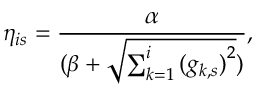<formula> <loc_0><loc_0><loc_500><loc_500>\eta _ { i s } = \frac { \alpha } { ( \beta + \sqrt { \sum _ { k = 1 } ^ { i } { ( g _ { k , s } ) } ^ { 2 } } ) } ,</formula> 